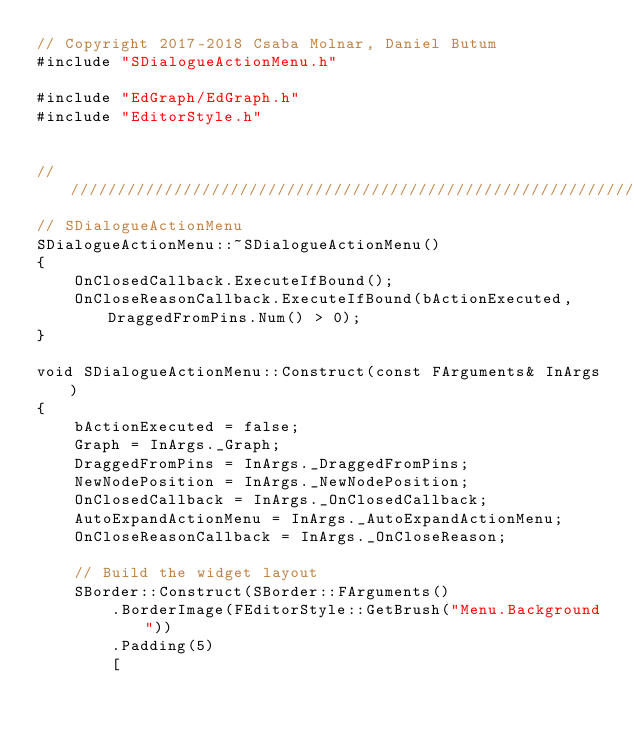<code> <loc_0><loc_0><loc_500><loc_500><_C++_>// Copyright 2017-2018 Csaba Molnar, Daniel Butum
#include "SDialogueActionMenu.h"

#include "EdGraph/EdGraph.h"
#include "EditorStyle.h"


////////////////////////////////////////////////////////////////////////////////////////////////////////////////
// SDialogueActionMenu
SDialogueActionMenu::~SDialogueActionMenu()
{
	OnClosedCallback.ExecuteIfBound();
	OnCloseReasonCallback.ExecuteIfBound(bActionExecuted, DraggedFromPins.Num() > 0);
}

void SDialogueActionMenu::Construct(const FArguments& InArgs)
{
	bActionExecuted = false;
	Graph = InArgs._Graph;
	DraggedFromPins = InArgs._DraggedFromPins;
	NewNodePosition = InArgs._NewNodePosition;
	OnClosedCallback = InArgs._OnClosedCallback;
	AutoExpandActionMenu = InArgs._AutoExpandActionMenu;
	OnCloseReasonCallback = InArgs._OnCloseReason;

	// Build the widget layout
	SBorder::Construct(SBorder::FArguments()
		.BorderImage(FEditorStyle::GetBrush("Menu.Background"))
		.Padding(5)
		[</code> 